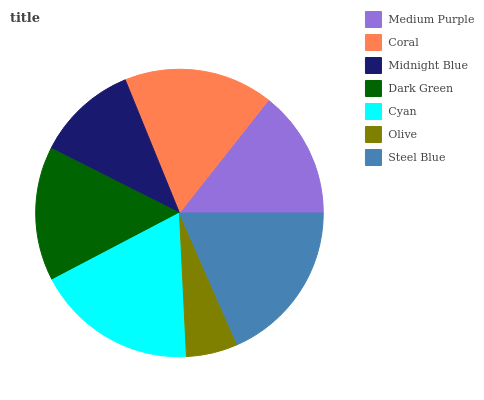Is Olive the minimum?
Answer yes or no. Yes. Is Steel Blue the maximum?
Answer yes or no. Yes. Is Coral the minimum?
Answer yes or no. No. Is Coral the maximum?
Answer yes or no. No. Is Coral greater than Medium Purple?
Answer yes or no. Yes. Is Medium Purple less than Coral?
Answer yes or no. Yes. Is Medium Purple greater than Coral?
Answer yes or no. No. Is Coral less than Medium Purple?
Answer yes or no. No. Is Dark Green the high median?
Answer yes or no. Yes. Is Dark Green the low median?
Answer yes or no. Yes. Is Coral the high median?
Answer yes or no. No. Is Steel Blue the low median?
Answer yes or no. No. 